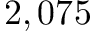<formula> <loc_0><loc_0><loc_500><loc_500>2 , 0 7 5</formula> 